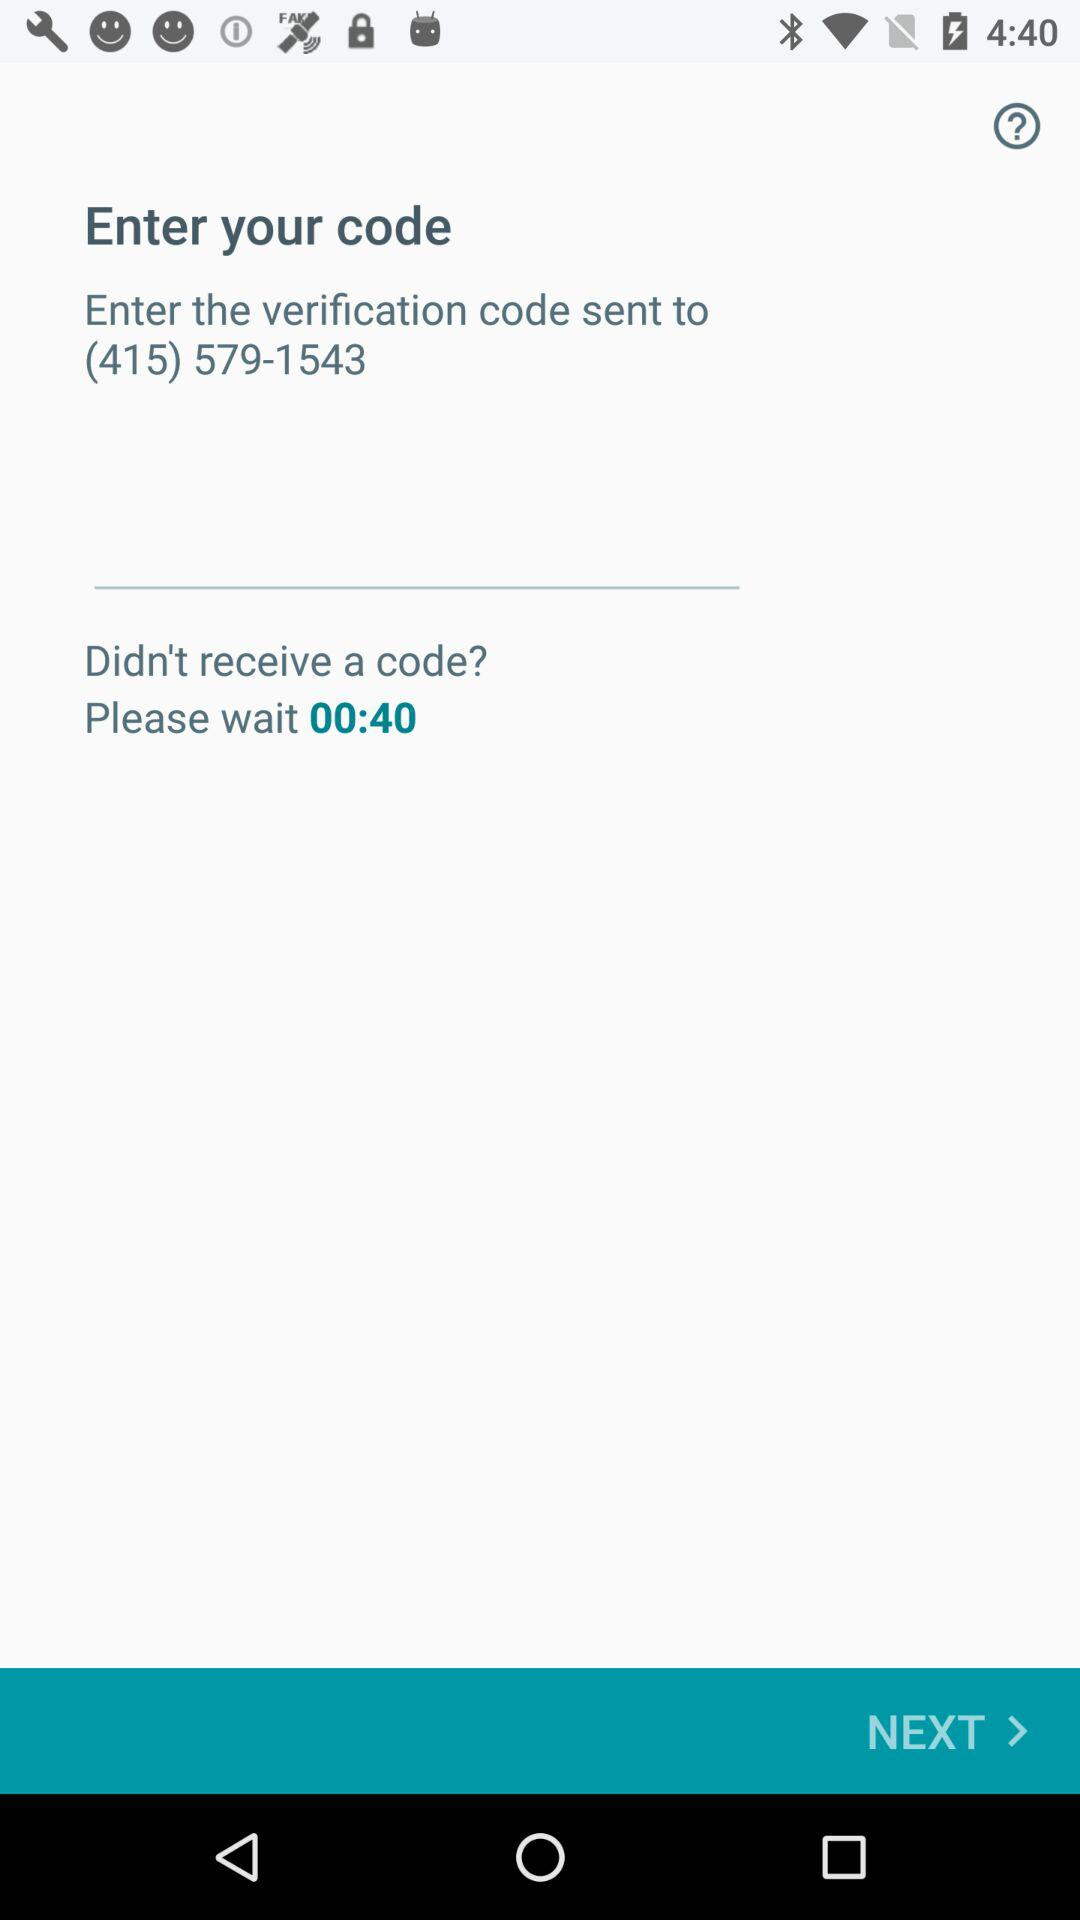What is the phone number to which the verification code is sent? The phone number is (415) 579-1543. 